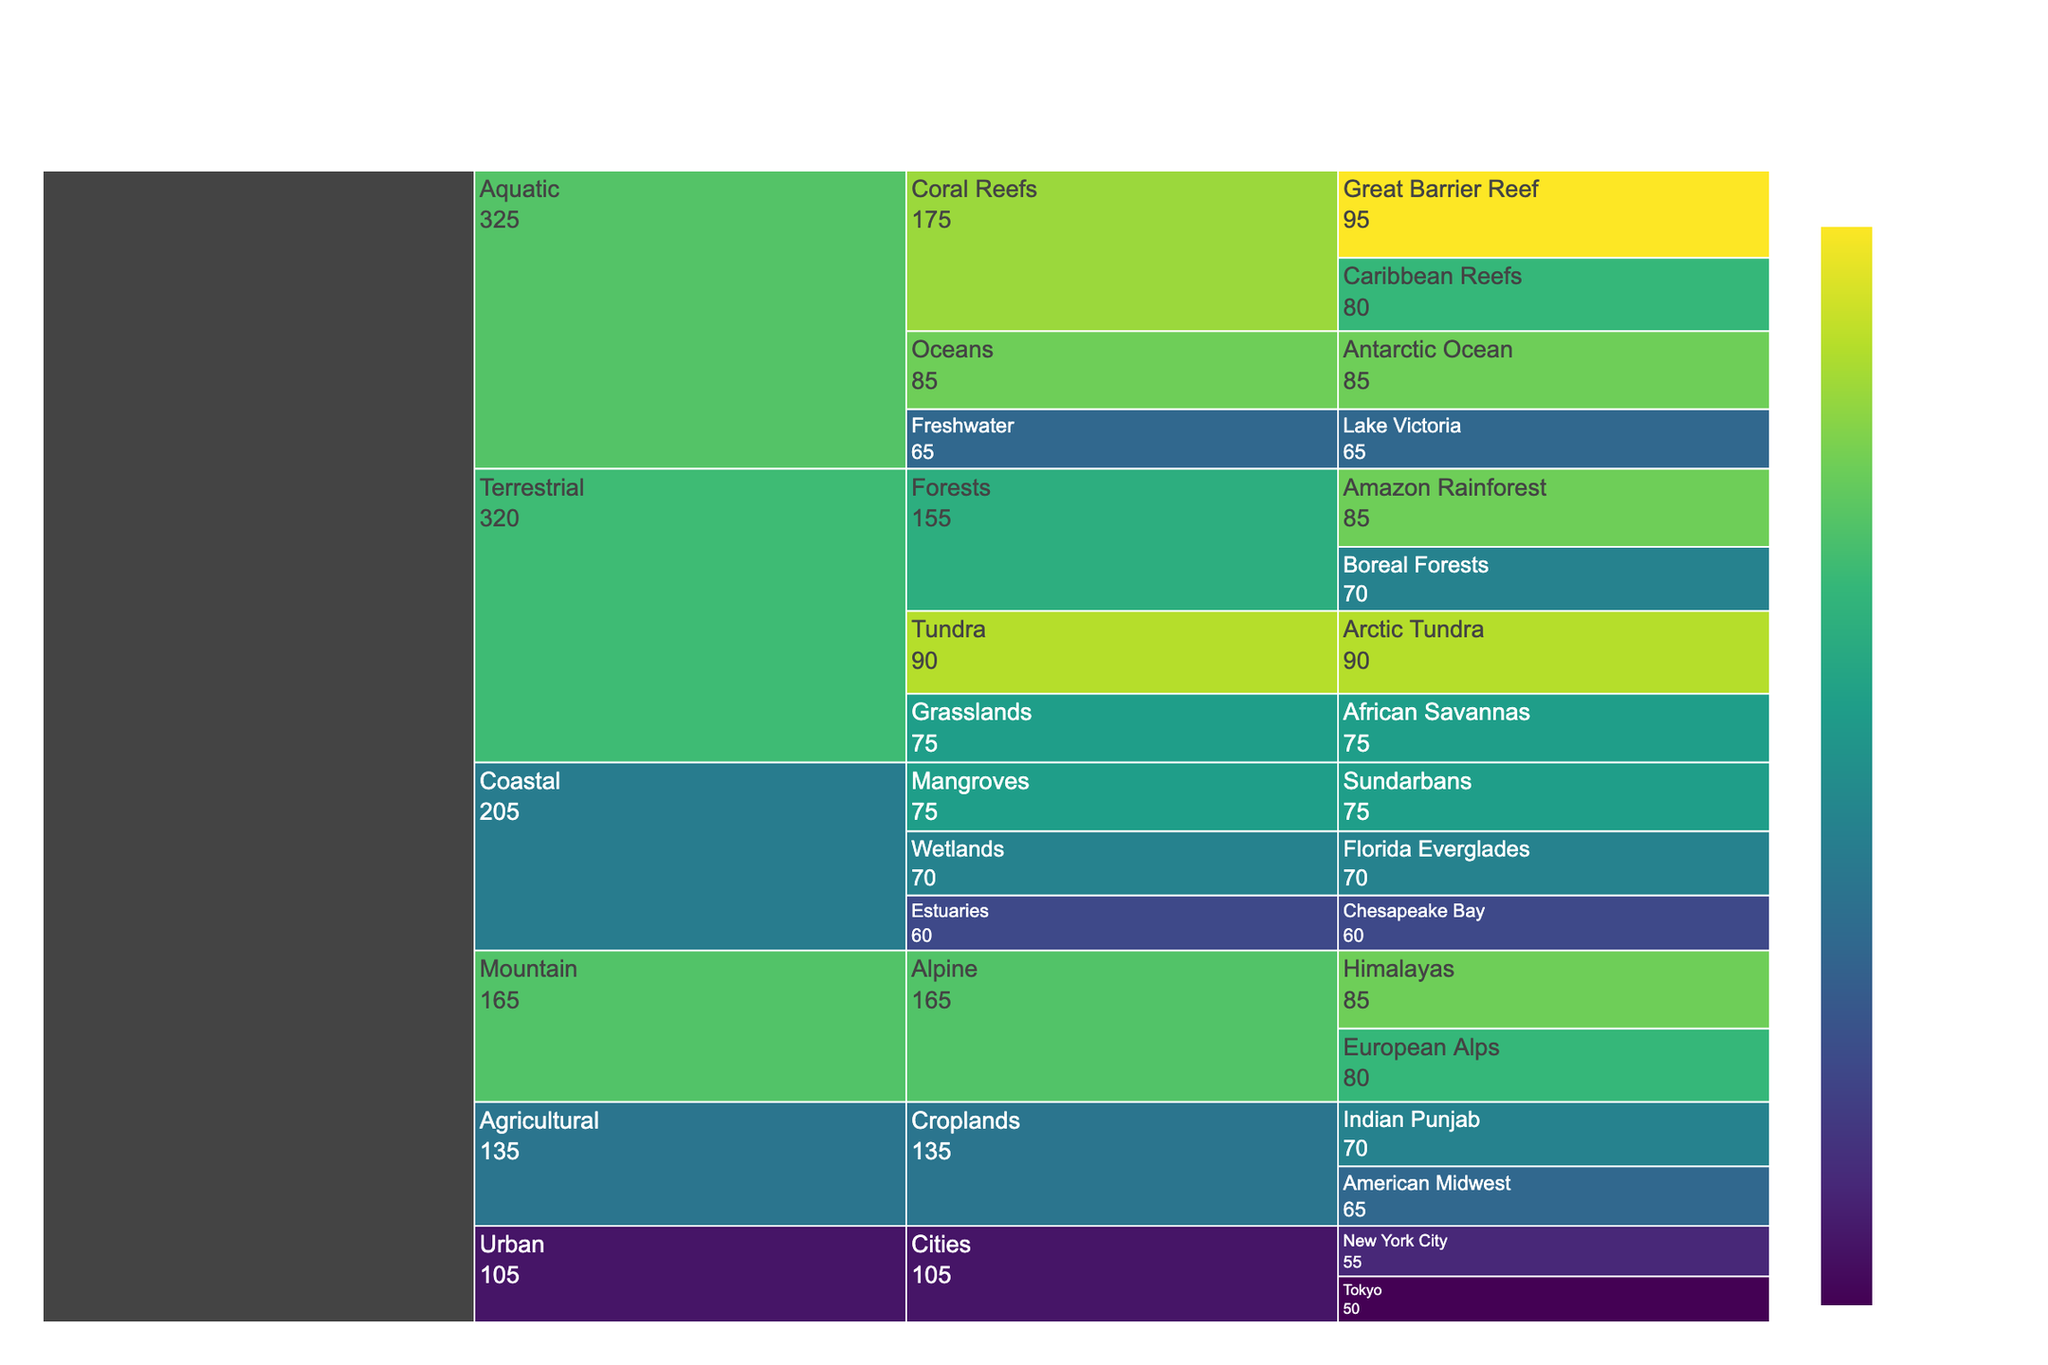what is the title of the figure? The title of the figure is typically displayed at the top of the chart. In this case, it is specified in the code as "Climate Change Impact Severity Across Ecosystems and Regions".
Answer: Climate Change Impact Severity Across Ecosystems and Regions Which ecosystem has the highest impact severity value? To determine the ecosystem with the highest impact severity, we can compare the highest values under each ecosystem category. The impact severity for the Terrestrial (Arctic Tundra), Aquatic (Great Barrier Reef), and Mountain (Himalayas) ecosystems are all very high. Among these, the Great Barrier Reef has the highest value of 95.
Answer: Great Barrier Reef What is the impact severity for the Amazon Rainforest, and how does it compare to the Boreal Forests? The impact severity values for the Amazon Rainforest and Boreal Forests are listed as 85 and 70, respectively. By comparing them, we can see that the Amazon Rainforest has a higher impact severity by 15 points.
Answer: Amazon Rainforest: 85, Boreal Forests: 70 What is the average impact severity of the Croplands across the American Midwest and Indian Punjab? To find the average impact severity of the Croplands, we add the severity values of the American Midwest (65) and Indian Punjab (70), and then divide by 2. (65 + 70) / 2 = 67.5
Answer: 67.5 Which region within the Coastal category has the lowest impact severity? Within the Coastal category, the regions are Mangroves (75), Wetlands (70), and Estuaries (60). Estuaries have the lowest impact severity value.
Answer: Estuaries How does the impact severity of Alpine ecosystems in the European Alps compare to that in the Himalayas? The impact severity for Alpine ecosystems is 80 for the European Alps and 85 for the Himalayas. To compare, the Himalayas have a higher impact severity by 5 points.
Answer: European Alps: 80, Himalayas: 85 Which Urban region has a higher impact severity, New York City or Tokyo? The impact severity values for the Urban areas are listed as 55 for New York City and 50 for Tokyo. Therefore, New York City has a higher impact severity than Tokyo.
Answer: New York City What is the summed impact severity of the Tundra and Coral Reefs categories? Tundra has an impact severity of 90, and Coral Reefs include the Great Barrier Reef (95) and Caribbean Reefs (80). To find the total impact severity, we sum these values together: 90 + 95 + 80 = 265.
Answer: 265 